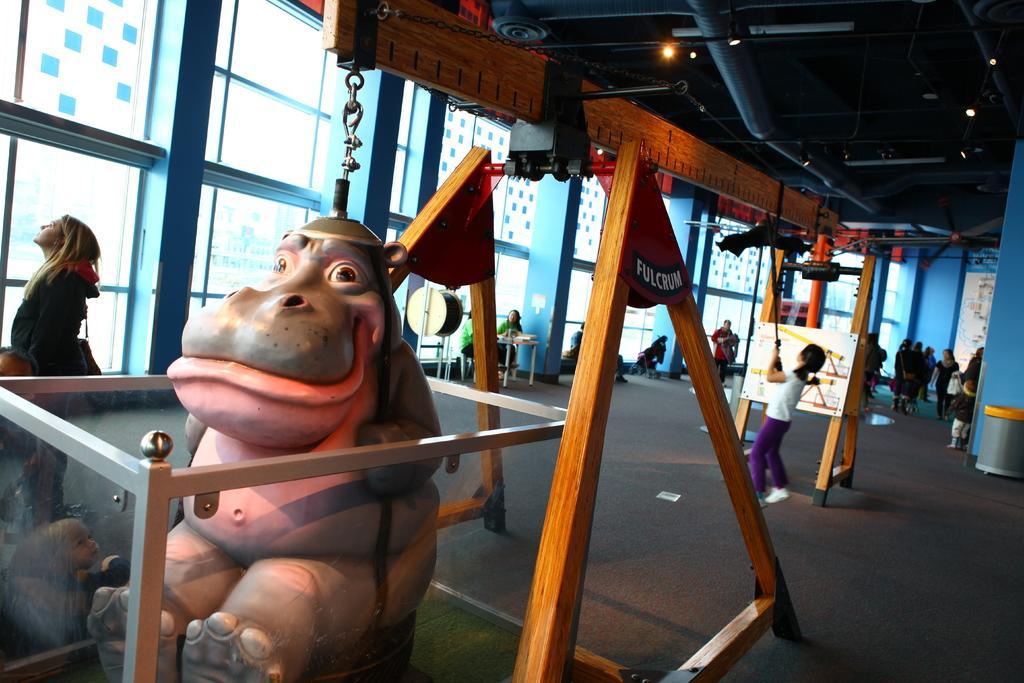Could you give a brief overview of what you see in this image? This picture describes about group of people, few are standing, few are seated and few are walking, in this we can find a toy, and it is connected to the cable, in the background we can see a notice board, light and metal rods. 